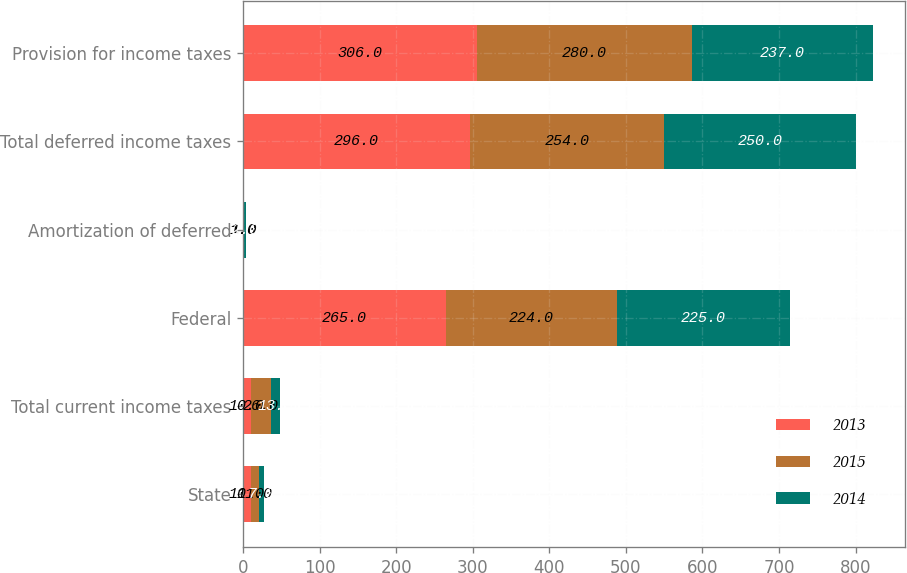Convert chart. <chart><loc_0><loc_0><loc_500><loc_500><stacked_bar_chart><ecel><fcel>State<fcel>Total current income taxes<fcel>Federal<fcel>Amortization of deferred<fcel>Total deferred income taxes<fcel>Provision for income taxes<nl><fcel>2013<fcel>10<fcel>10<fcel>265<fcel>1<fcel>296<fcel>306<nl><fcel>2015<fcel>11<fcel>26<fcel>224<fcel>1<fcel>254<fcel>280<nl><fcel>2014<fcel>7<fcel>13<fcel>225<fcel>2<fcel>250<fcel>237<nl></chart> 